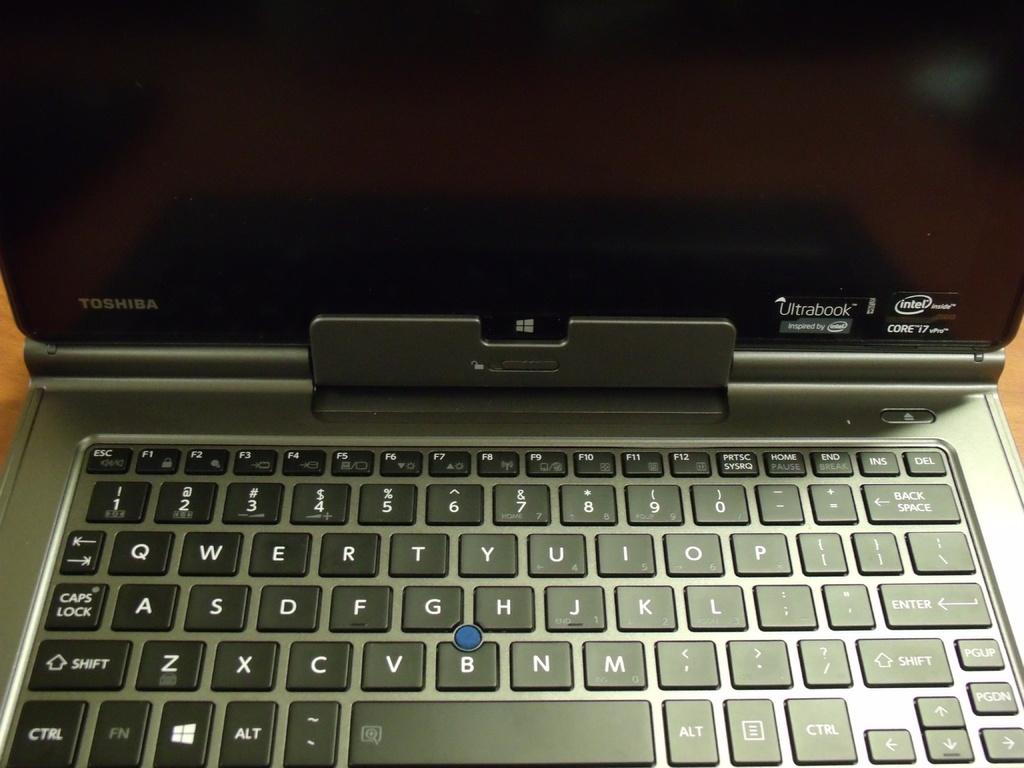What brand is this?
Your response must be concise. Toshiba. 